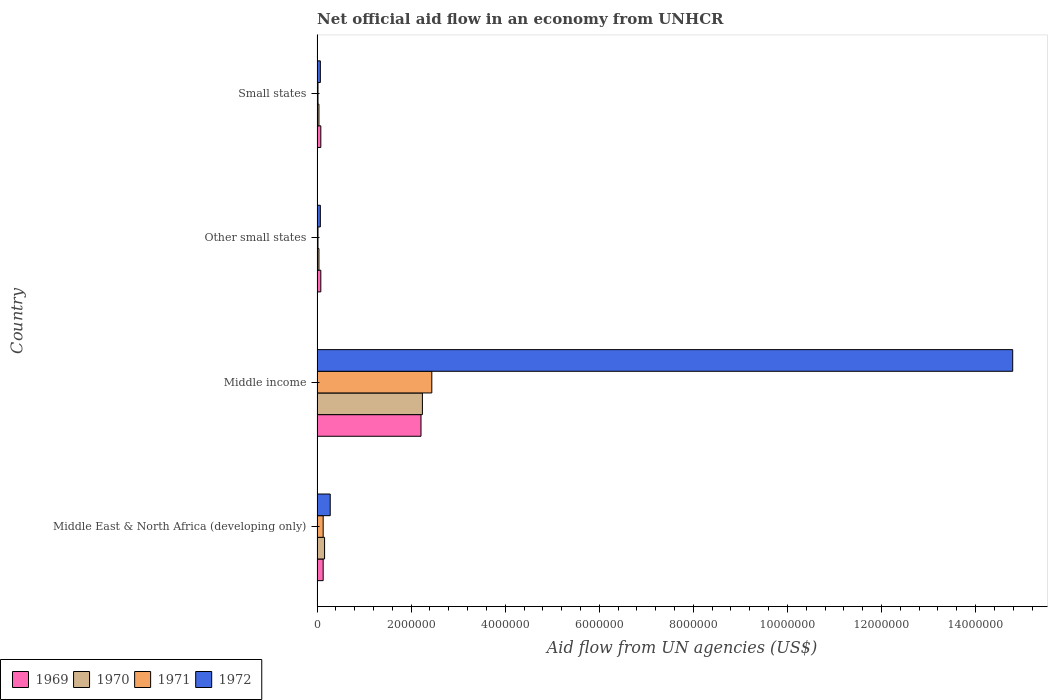How many different coloured bars are there?
Keep it short and to the point. 4. How many groups of bars are there?
Offer a terse response. 4. Are the number of bars on each tick of the Y-axis equal?
Ensure brevity in your answer.  Yes. How many bars are there on the 3rd tick from the top?
Make the answer very short. 4. What is the label of the 1st group of bars from the top?
Offer a very short reply. Small states. What is the net official aid flow in 1972 in Other small states?
Keep it short and to the point. 7.00e+04. Across all countries, what is the maximum net official aid flow in 1971?
Offer a terse response. 2.44e+06. In which country was the net official aid flow in 1969 maximum?
Your response must be concise. Middle income. In which country was the net official aid flow in 1972 minimum?
Provide a short and direct response. Other small states. What is the total net official aid flow in 1971 in the graph?
Keep it short and to the point. 2.61e+06. What is the difference between the net official aid flow in 1972 in Middle income and that in Small states?
Keep it short and to the point. 1.47e+07. What is the average net official aid flow in 1970 per country?
Provide a succinct answer. 6.20e+05. In how many countries, is the net official aid flow in 1969 greater than 10400000 US$?
Your response must be concise. 0. What is the ratio of the net official aid flow in 1972 in Middle East & North Africa (developing only) to that in Middle income?
Keep it short and to the point. 0.02. Is the net official aid flow in 1971 in Middle income less than that in Other small states?
Your response must be concise. No. What is the difference between the highest and the second highest net official aid flow in 1971?
Offer a terse response. 2.31e+06. What is the difference between the highest and the lowest net official aid flow in 1970?
Your response must be concise. 2.20e+06. Is it the case that in every country, the sum of the net official aid flow in 1969 and net official aid flow in 1971 is greater than the sum of net official aid flow in 1970 and net official aid flow in 1972?
Provide a succinct answer. No. What does the 1st bar from the top in Small states represents?
Ensure brevity in your answer.  1972. What does the 3rd bar from the bottom in Other small states represents?
Your answer should be very brief. 1971. Is it the case that in every country, the sum of the net official aid flow in 1972 and net official aid flow in 1970 is greater than the net official aid flow in 1971?
Make the answer very short. Yes. Are all the bars in the graph horizontal?
Make the answer very short. Yes. What is the difference between two consecutive major ticks on the X-axis?
Give a very brief answer. 2.00e+06. Does the graph contain grids?
Your response must be concise. No. What is the title of the graph?
Your answer should be very brief. Net official aid flow in an economy from UNHCR. What is the label or title of the X-axis?
Offer a terse response. Aid flow from UN agencies (US$). What is the Aid flow from UN agencies (US$) in 1969 in Middle East & North Africa (developing only)?
Your response must be concise. 1.30e+05. What is the Aid flow from UN agencies (US$) of 1970 in Middle East & North Africa (developing only)?
Offer a terse response. 1.60e+05. What is the Aid flow from UN agencies (US$) in 1971 in Middle East & North Africa (developing only)?
Keep it short and to the point. 1.30e+05. What is the Aid flow from UN agencies (US$) of 1969 in Middle income?
Make the answer very short. 2.21e+06. What is the Aid flow from UN agencies (US$) of 1970 in Middle income?
Offer a terse response. 2.24e+06. What is the Aid flow from UN agencies (US$) of 1971 in Middle income?
Make the answer very short. 2.44e+06. What is the Aid flow from UN agencies (US$) in 1972 in Middle income?
Ensure brevity in your answer.  1.48e+07. What is the Aid flow from UN agencies (US$) in 1969 in Other small states?
Keep it short and to the point. 8.00e+04. What is the Aid flow from UN agencies (US$) of 1972 in Other small states?
Your response must be concise. 7.00e+04. What is the Aid flow from UN agencies (US$) in 1971 in Small states?
Your answer should be very brief. 2.00e+04. What is the Aid flow from UN agencies (US$) of 1972 in Small states?
Give a very brief answer. 7.00e+04. Across all countries, what is the maximum Aid flow from UN agencies (US$) in 1969?
Provide a succinct answer. 2.21e+06. Across all countries, what is the maximum Aid flow from UN agencies (US$) in 1970?
Give a very brief answer. 2.24e+06. Across all countries, what is the maximum Aid flow from UN agencies (US$) in 1971?
Give a very brief answer. 2.44e+06. Across all countries, what is the maximum Aid flow from UN agencies (US$) in 1972?
Provide a succinct answer. 1.48e+07. Across all countries, what is the minimum Aid flow from UN agencies (US$) in 1970?
Offer a terse response. 4.00e+04. What is the total Aid flow from UN agencies (US$) of 1969 in the graph?
Your response must be concise. 2.50e+06. What is the total Aid flow from UN agencies (US$) in 1970 in the graph?
Your response must be concise. 2.48e+06. What is the total Aid flow from UN agencies (US$) of 1971 in the graph?
Your answer should be compact. 2.61e+06. What is the total Aid flow from UN agencies (US$) in 1972 in the graph?
Your answer should be compact. 1.52e+07. What is the difference between the Aid flow from UN agencies (US$) in 1969 in Middle East & North Africa (developing only) and that in Middle income?
Offer a very short reply. -2.08e+06. What is the difference between the Aid flow from UN agencies (US$) of 1970 in Middle East & North Africa (developing only) and that in Middle income?
Your answer should be very brief. -2.08e+06. What is the difference between the Aid flow from UN agencies (US$) in 1971 in Middle East & North Africa (developing only) and that in Middle income?
Provide a short and direct response. -2.31e+06. What is the difference between the Aid flow from UN agencies (US$) in 1972 in Middle East & North Africa (developing only) and that in Middle income?
Provide a short and direct response. -1.45e+07. What is the difference between the Aid flow from UN agencies (US$) of 1969 in Middle East & North Africa (developing only) and that in Other small states?
Ensure brevity in your answer.  5.00e+04. What is the difference between the Aid flow from UN agencies (US$) in 1969 in Middle East & North Africa (developing only) and that in Small states?
Your response must be concise. 5.00e+04. What is the difference between the Aid flow from UN agencies (US$) in 1970 in Middle East & North Africa (developing only) and that in Small states?
Offer a terse response. 1.20e+05. What is the difference between the Aid flow from UN agencies (US$) of 1969 in Middle income and that in Other small states?
Your answer should be very brief. 2.13e+06. What is the difference between the Aid flow from UN agencies (US$) in 1970 in Middle income and that in Other small states?
Your answer should be very brief. 2.20e+06. What is the difference between the Aid flow from UN agencies (US$) of 1971 in Middle income and that in Other small states?
Provide a short and direct response. 2.42e+06. What is the difference between the Aid flow from UN agencies (US$) of 1972 in Middle income and that in Other small states?
Your answer should be compact. 1.47e+07. What is the difference between the Aid flow from UN agencies (US$) in 1969 in Middle income and that in Small states?
Keep it short and to the point. 2.13e+06. What is the difference between the Aid flow from UN agencies (US$) in 1970 in Middle income and that in Small states?
Your answer should be very brief. 2.20e+06. What is the difference between the Aid flow from UN agencies (US$) of 1971 in Middle income and that in Small states?
Offer a very short reply. 2.42e+06. What is the difference between the Aid flow from UN agencies (US$) of 1972 in Middle income and that in Small states?
Provide a short and direct response. 1.47e+07. What is the difference between the Aid flow from UN agencies (US$) of 1969 in Other small states and that in Small states?
Your answer should be very brief. 0. What is the difference between the Aid flow from UN agencies (US$) in 1970 in Other small states and that in Small states?
Your answer should be compact. 0. What is the difference between the Aid flow from UN agencies (US$) of 1972 in Other small states and that in Small states?
Your answer should be compact. 0. What is the difference between the Aid flow from UN agencies (US$) in 1969 in Middle East & North Africa (developing only) and the Aid flow from UN agencies (US$) in 1970 in Middle income?
Offer a terse response. -2.11e+06. What is the difference between the Aid flow from UN agencies (US$) of 1969 in Middle East & North Africa (developing only) and the Aid flow from UN agencies (US$) of 1971 in Middle income?
Give a very brief answer. -2.31e+06. What is the difference between the Aid flow from UN agencies (US$) in 1969 in Middle East & North Africa (developing only) and the Aid flow from UN agencies (US$) in 1972 in Middle income?
Your answer should be compact. -1.47e+07. What is the difference between the Aid flow from UN agencies (US$) of 1970 in Middle East & North Africa (developing only) and the Aid flow from UN agencies (US$) of 1971 in Middle income?
Your response must be concise. -2.28e+06. What is the difference between the Aid flow from UN agencies (US$) in 1970 in Middle East & North Africa (developing only) and the Aid flow from UN agencies (US$) in 1972 in Middle income?
Keep it short and to the point. -1.46e+07. What is the difference between the Aid flow from UN agencies (US$) in 1971 in Middle East & North Africa (developing only) and the Aid flow from UN agencies (US$) in 1972 in Middle income?
Make the answer very short. -1.47e+07. What is the difference between the Aid flow from UN agencies (US$) in 1969 in Middle East & North Africa (developing only) and the Aid flow from UN agencies (US$) in 1970 in Other small states?
Your response must be concise. 9.00e+04. What is the difference between the Aid flow from UN agencies (US$) of 1969 in Middle East & North Africa (developing only) and the Aid flow from UN agencies (US$) of 1971 in Other small states?
Make the answer very short. 1.10e+05. What is the difference between the Aid flow from UN agencies (US$) in 1969 in Middle East & North Africa (developing only) and the Aid flow from UN agencies (US$) in 1972 in Other small states?
Offer a very short reply. 6.00e+04. What is the difference between the Aid flow from UN agencies (US$) in 1969 in Middle East & North Africa (developing only) and the Aid flow from UN agencies (US$) in 1970 in Small states?
Offer a terse response. 9.00e+04. What is the difference between the Aid flow from UN agencies (US$) in 1969 in Middle East & North Africa (developing only) and the Aid flow from UN agencies (US$) in 1972 in Small states?
Provide a short and direct response. 6.00e+04. What is the difference between the Aid flow from UN agencies (US$) in 1969 in Middle income and the Aid flow from UN agencies (US$) in 1970 in Other small states?
Give a very brief answer. 2.17e+06. What is the difference between the Aid flow from UN agencies (US$) in 1969 in Middle income and the Aid flow from UN agencies (US$) in 1971 in Other small states?
Provide a succinct answer. 2.19e+06. What is the difference between the Aid flow from UN agencies (US$) in 1969 in Middle income and the Aid flow from UN agencies (US$) in 1972 in Other small states?
Keep it short and to the point. 2.14e+06. What is the difference between the Aid flow from UN agencies (US$) of 1970 in Middle income and the Aid flow from UN agencies (US$) of 1971 in Other small states?
Offer a terse response. 2.22e+06. What is the difference between the Aid flow from UN agencies (US$) in 1970 in Middle income and the Aid flow from UN agencies (US$) in 1972 in Other small states?
Keep it short and to the point. 2.17e+06. What is the difference between the Aid flow from UN agencies (US$) of 1971 in Middle income and the Aid flow from UN agencies (US$) of 1972 in Other small states?
Your response must be concise. 2.37e+06. What is the difference between the Aid flow from UN agencies (US$) in 1969 in Middle income and the Aid flow from UN agencies (US$) in 1970 in Small states?
Offer a terse response. 2.17e+06. What is the difference between the Aid flow from UN agencies (US$) of 1969 in Middle income and the Aid flow from UN agencies (US$) of 1971 in Small states?
Provide a short and direct response. 2.19e+06. What is the difference between the Aid flow from UN agencies (US$) of 1969 in Middle income and the Aid flow from UN agencies (US$) of 1972 in Small states?
Your answer should be very brief. 2.14e+06. What is the difference between the Aid flow from UN agencies (US$) in 1970 in Middle income and the Aid flow from UN agencies (US$) in 1971 in Small states?
Make the answer very short. 2.22e+06. What is the difference between the Aid flow from UN agencies (US$) in 1970 in Middle income and the Aid flow from UN agencies (US$) in 1972 in Small states?
Ensure brevity in your answer.  2.17e+06. What is the difference between the Aid flow from UN agencies (US$) of 1971 in Middle income and the Aid flow from UN agencies (US$) of 1972 in Small states?
Offer a very short reply. 2.37e+06. What is the difference between the Aid flow from UN agencies (US$) in 1969 in Other small states and the Aid flow from UN agencies (US$) in 1972 in Small states?
Offer a very short reply. 10000. What is the average Aid flow from UN agencies (US$) in 1969 per country?
Your answer should be very brief. 6.25e+05. What is the average Aid flow from UN agencies (US$) in 1970 per country?
Your answer should be very brief. 6.20e+05. What is the average Aid flow from UN agencies (US$) of 1971 per country?
Ensure brevity in your answer.  6.52e+05. What is the average Aid flow from UN agencies (US$) in 1972 per country?
Provide a succinct answer. 3.80e+06. What is the difference between the Aid flow from UN agencies (US$) in 1969 and Aid flow from UN agencies (US$) in 1970 in Middle East & North Africa (developing only)?
Make the answer very short. -3.00e+04. What is the difference between the Aid flow from UN agencies (US$) of 1969 and Aid flow from UN agencies (US$) of 1971 in Middle East & North Africa (developing only)?
Offer a terse response. 0. What is the difference between the Aid flow from UN agencies (US$) of 1969 and Aid flow from UN agencies (US$) of 1972 in Middle East & North Africa (developing only)?
Ensure brevity in your answer.  -1.50e+05. What is the difference between the Aid flow from UN agencies (US$) in 1970 and Aid flow from UN agencies (US$) in 1972 in Middle East & North Africa (developing only)?
Offer a terse response. -1.20e+05. What is the difference between the Aid flow from UN agencies (US$) in 1971 and Aid flow from UN agencies (US$) in 1972 in Middle East & North Africa (developing only)?
Your response must be concise. -1.50e+05. What is the difference between the Aid flow from UN agencies (US$) in 1969 and Aid flow from UN agencies (US$) in 1971 in Middle income?
Provide a short and direct response. -2.30e+05. What is the difference between the Aid flow from UN agencies (US$) of 1969 and Aid flow from UN agencies (US$) of 1972 in Middle income?
Provide a short and direct response. -1.26e+07. What is the difference between the Aid flow from UN agencies (US$) in 1970 and Aid flow from UN agencies (US$) in 1971 in Middle income?
Provide a succinct answer. -2.00e+05. What is the difference between the Aid flow from UN agencies (US$) of 1970 and Aid flow from UN agencies (US$) of 1972 in Middle income?
Provide a short and direct response. -1.26e+07. What is the difference between the Aid flow from UN agencies (US$) in 1971 and Aid flow from UN agencies (US$) in 1972 in Middle income?
Your response must be concise. -1.24e+07. What is the difference between the Aid flow from UN agencies (US$) of 1969 and Aid flow from UN agencies (US$) of 1970 in Other small states?
Keep it short and to the point. 4.00e+04. What is the difference between the Aid flow from UN agencies (US$) in 1970 and Aid flow from UN agencies (US$) in 1972 in Other small states?
Offer a terse response. -3.00e+04. What is the difference between the Aid flow from UN agencies (US$) of 1969 and Aid flow from UN agencies (US$) of 1970 in Small states?
Ensure brevity in your answer.  4.00e+04. What is the difference between the Aid flow from UN agencies (US$) of 1969 and Aid flow from UN agencies (US$) of 1972 in Small states?
Ensure brevity in your answer.  10000. What is the difference between the Aid flow from UN agencies (US$) in 1970 and Aid flow from UN agencies (US$) in 1972 in Small states?
Provide a short and direct response. -3.00e+04. What is the ratio of the Aid flow from UN agencies (US$) in 1969 in Middle East & North Africa (developing only) to that in Middle income?
Keep it short and to the point. 0.06. What is the ratio of the Aid flow from UN agencies (US$) of 1970 in Middle East & North Africa (developing only) to that in Middle income?
Offer a terse response. 0.07. What is the ratio of the Aid flow from UN agencies (US$) in 1971 in Middle East & North Africa (developing only) to that in Middle income?
Ensure brevity in your answer.  0.05. What is the ratio of the Aid flow from UN agencies (US$) in 1972 in Middle East & North Africa (developing only) to that in Middle income?
Keep it short and to the point. 0.02. What is the ratio of the Aid flow from UN agencies (US$) of 1969 in Middle East & North Africa (developing only) to that in Other small states?
Provide a succinct answer. 1.62. What is the ratio of the Aid flow from UN agencies (US$) of 1970 in Middle East & North Africa (developing only) to that in Other small states?
Provide a succinct answer. 4. What is the ratio of the Aid flow from UN agencies (US$) of 1969 in Middle East & North Africa (developing only) to that in Small states?
Your answer should be very brief. 1.62. What is the ratio of the Aid flow from UN agencies (US$) in 1970 in Middle East & North Africa (developing only) to that in Small states?
Keep it short and to the point. 4. What is the ratio of the Aid flow from UN agencies (US$) in 1972 in Middle East & North Africa (developing only) to that in Small states?
Your answer should be very brief. 4. What is the ratio of the Aid flow from UN agencies (US$) of 1969 in Middle income to that in Other small states?
Give a very brief answer. 27.62. What is the ratio of the Aid flow from UN agencies (US$) in 1970 in Middle income to that in Other small states?
Your answer should be compact. 56. What is the ratio of the Aid flow from UN agencies (US$) of 1971 in Middle income to that in Other small states?
Make the answer very short. 122. What is the ratio of the Aid flow from UN agencies (US$) of 1972 in Middle income to that in Other small states?
Provide a succinct answer. 211.29. What is the ratio of the Aid flow from UN agencies (US$) in 1969 in Middle income to that in Small states?
Make the answer very short. 27.62. What is the ratio of the Aid flow from UN agencies (US$) of 1970 in Middle income to that in Small states?
Ensure brevity in your answer.  56. What is the ratio of the Aid flow from UN agencies (US$) in 1971 in Middle income to that in Small states?
Offer a terse response. 122. What is the ratio of the Aid flow from UN agencies (US$) of 1972 in Middle income to that in Small states?
Offer a terse response. 211.29. What is the ratio of the Aid flow from UN agencies (US$) of 1969 in Other small states to that in Small states?
Your answer should be very brief. 1. What is the ratio of the Aid flow from UN agencies (US$) in 1972 in Other small states to that in Small states?
Offer a very short reply. 1. What is the difference between the highest and the second highest Aid flow from UN agencies (US$) in 1969?
Your response must be concise. 2.08e+06. What is the difference between the highest and the second highest Aid flow from UN agencies (US$) in 1970?
Provide a short and direct response. 2.08e+06. What is the difference between the highest and the second highest Aid flow from UN agencies (US$) in 1971?
Give a very brief answer. 2.31e+06. What is the difference between the highest and the second highest Aid flow from UN agencies (US$) in 1972?
Offer a terse response. 1.45e+07. What is the difference between the highest and the lowest Aid flow from UN agencies (US$) in 1969?
Your answer should be very brief. 2.13e+06. What is the difference between the highest and the lowest Aid flow from UN agencies (US$) in 1970?
Provide a succinct answer. 2.20e+06. What is the difference between the highest and the lowest Aid flow from UN agencies (US$) in 1971?
Make the answer very short. 2.42e+06. What is the difference between the highest and the lowest Aid flow from UN agencies (US$) in 1972?
Your answer should be very brief. 1.47e+07. 